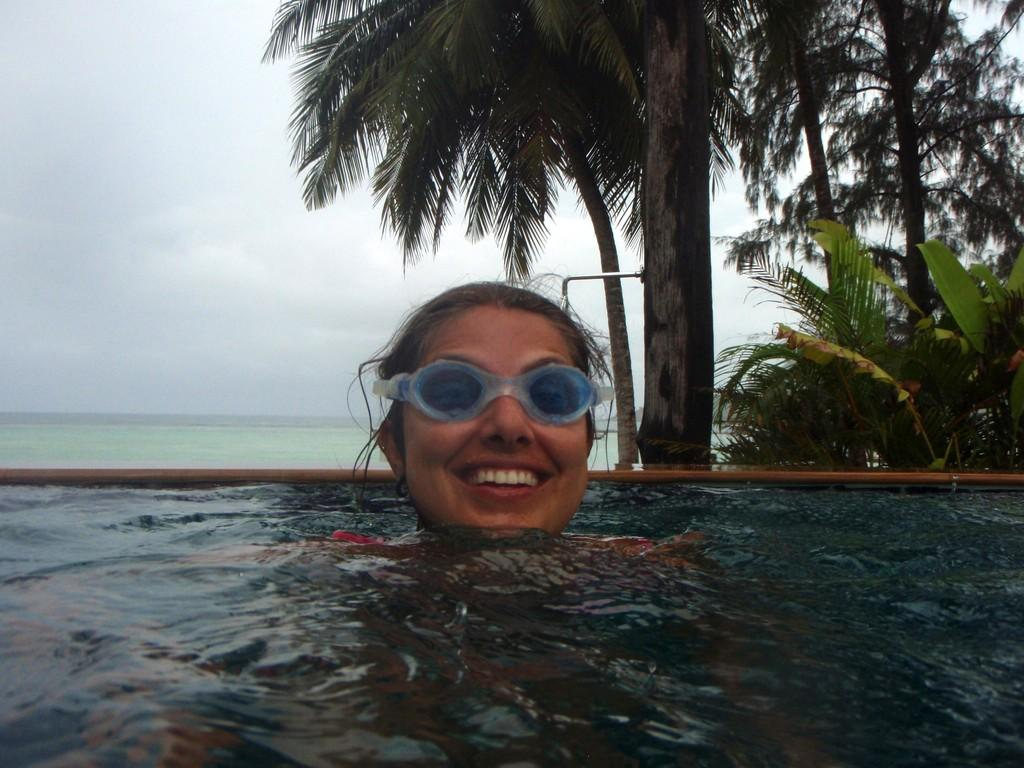What is the woman doing in the image? There is a woman in the swimming pool. What is the woman's expression in the image? The woman is smiling. What can be seen behind the woman in the image? There are trees behind the woman. What is visible in the background of the image? There is an ocean and the sky in the background. What type of cherries can be seen in the woman's hand in the image? There are no cherries present in the image; the woman is in a swimming pool and not holding any cherries. 